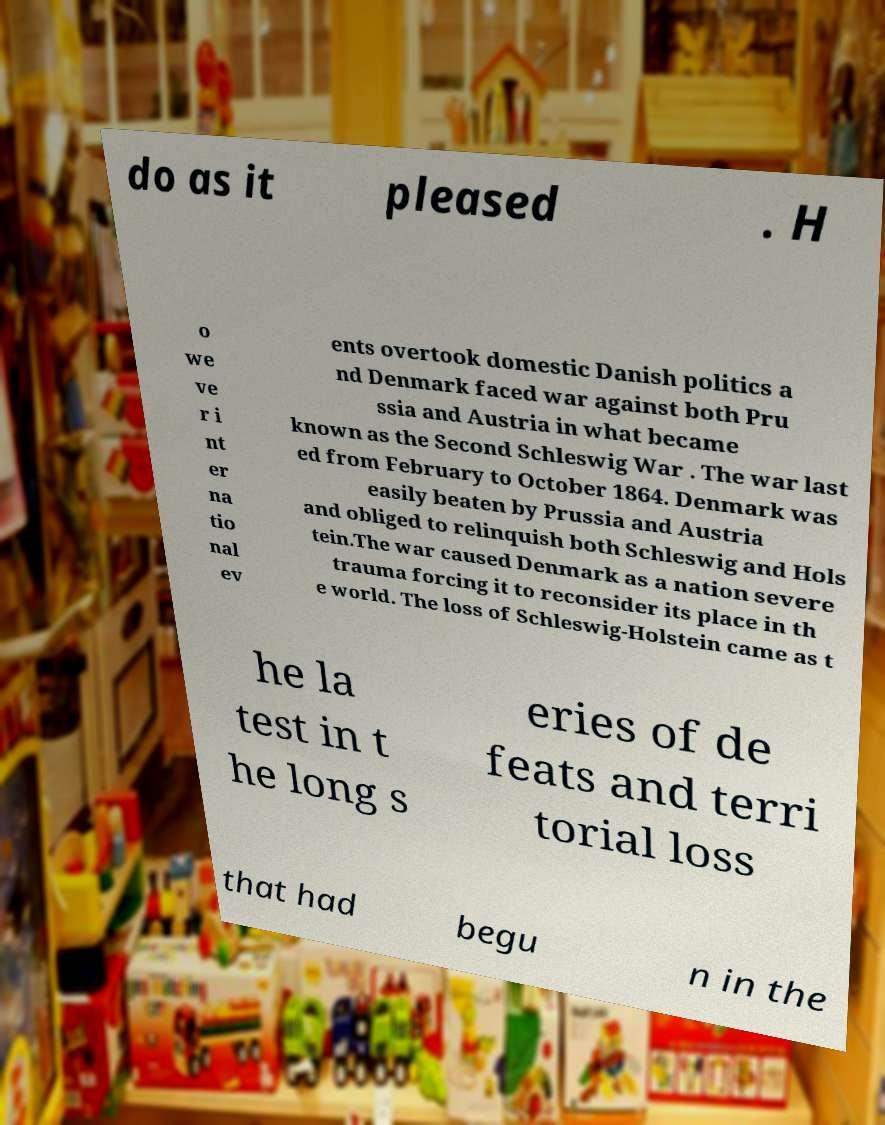There's text embedded in this image that I need extracted. Can you transcribe it verbatim? do as it pleased . H o we ve r i nt er na tio nal ev ents overtook domestic Danish politics a nd Denmark faced war against both Pru ssia and Austria in what became known as the Second Schleswig War . The war last ed from February to October 1864. Denmark was easily beaten by Prussia and Austria and obliged to relinquish both Schleswig and Hols tein.The war caused Denmark as a nation severe trauma forcing it to reconsider its place in th e world. The loss of Schleswig-Holstein came as t he la test in t he long s eries of de feats and terri torial loss that had begu n in the 